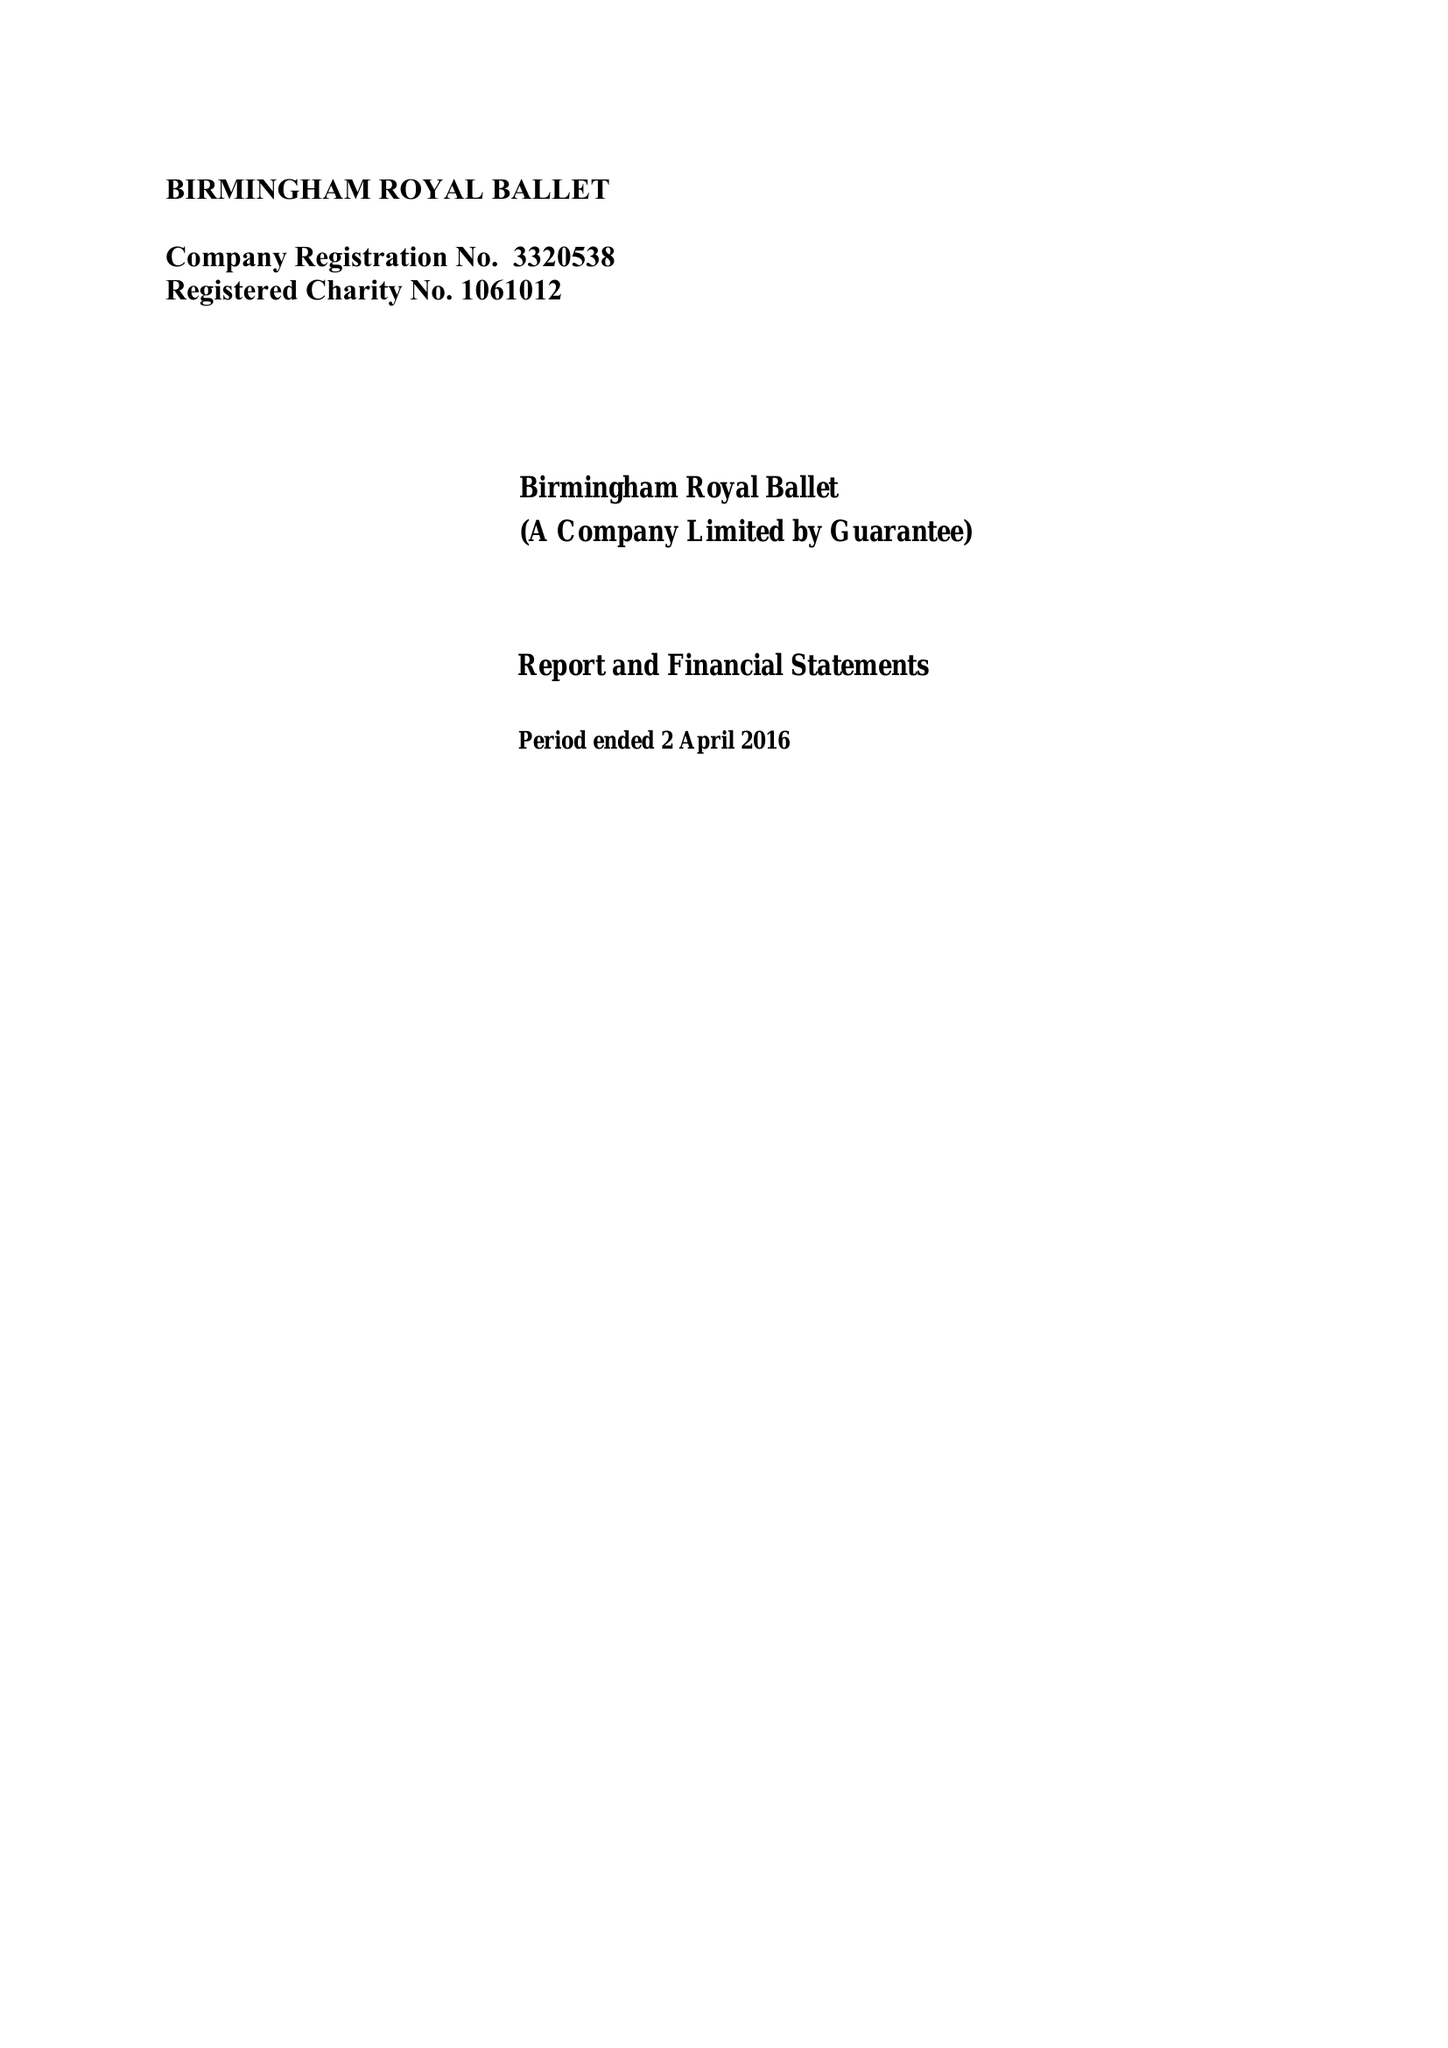What is the value for the spending_annually_in_british_pounds?
Answer the question using a single word or phrase. 13252857.00 